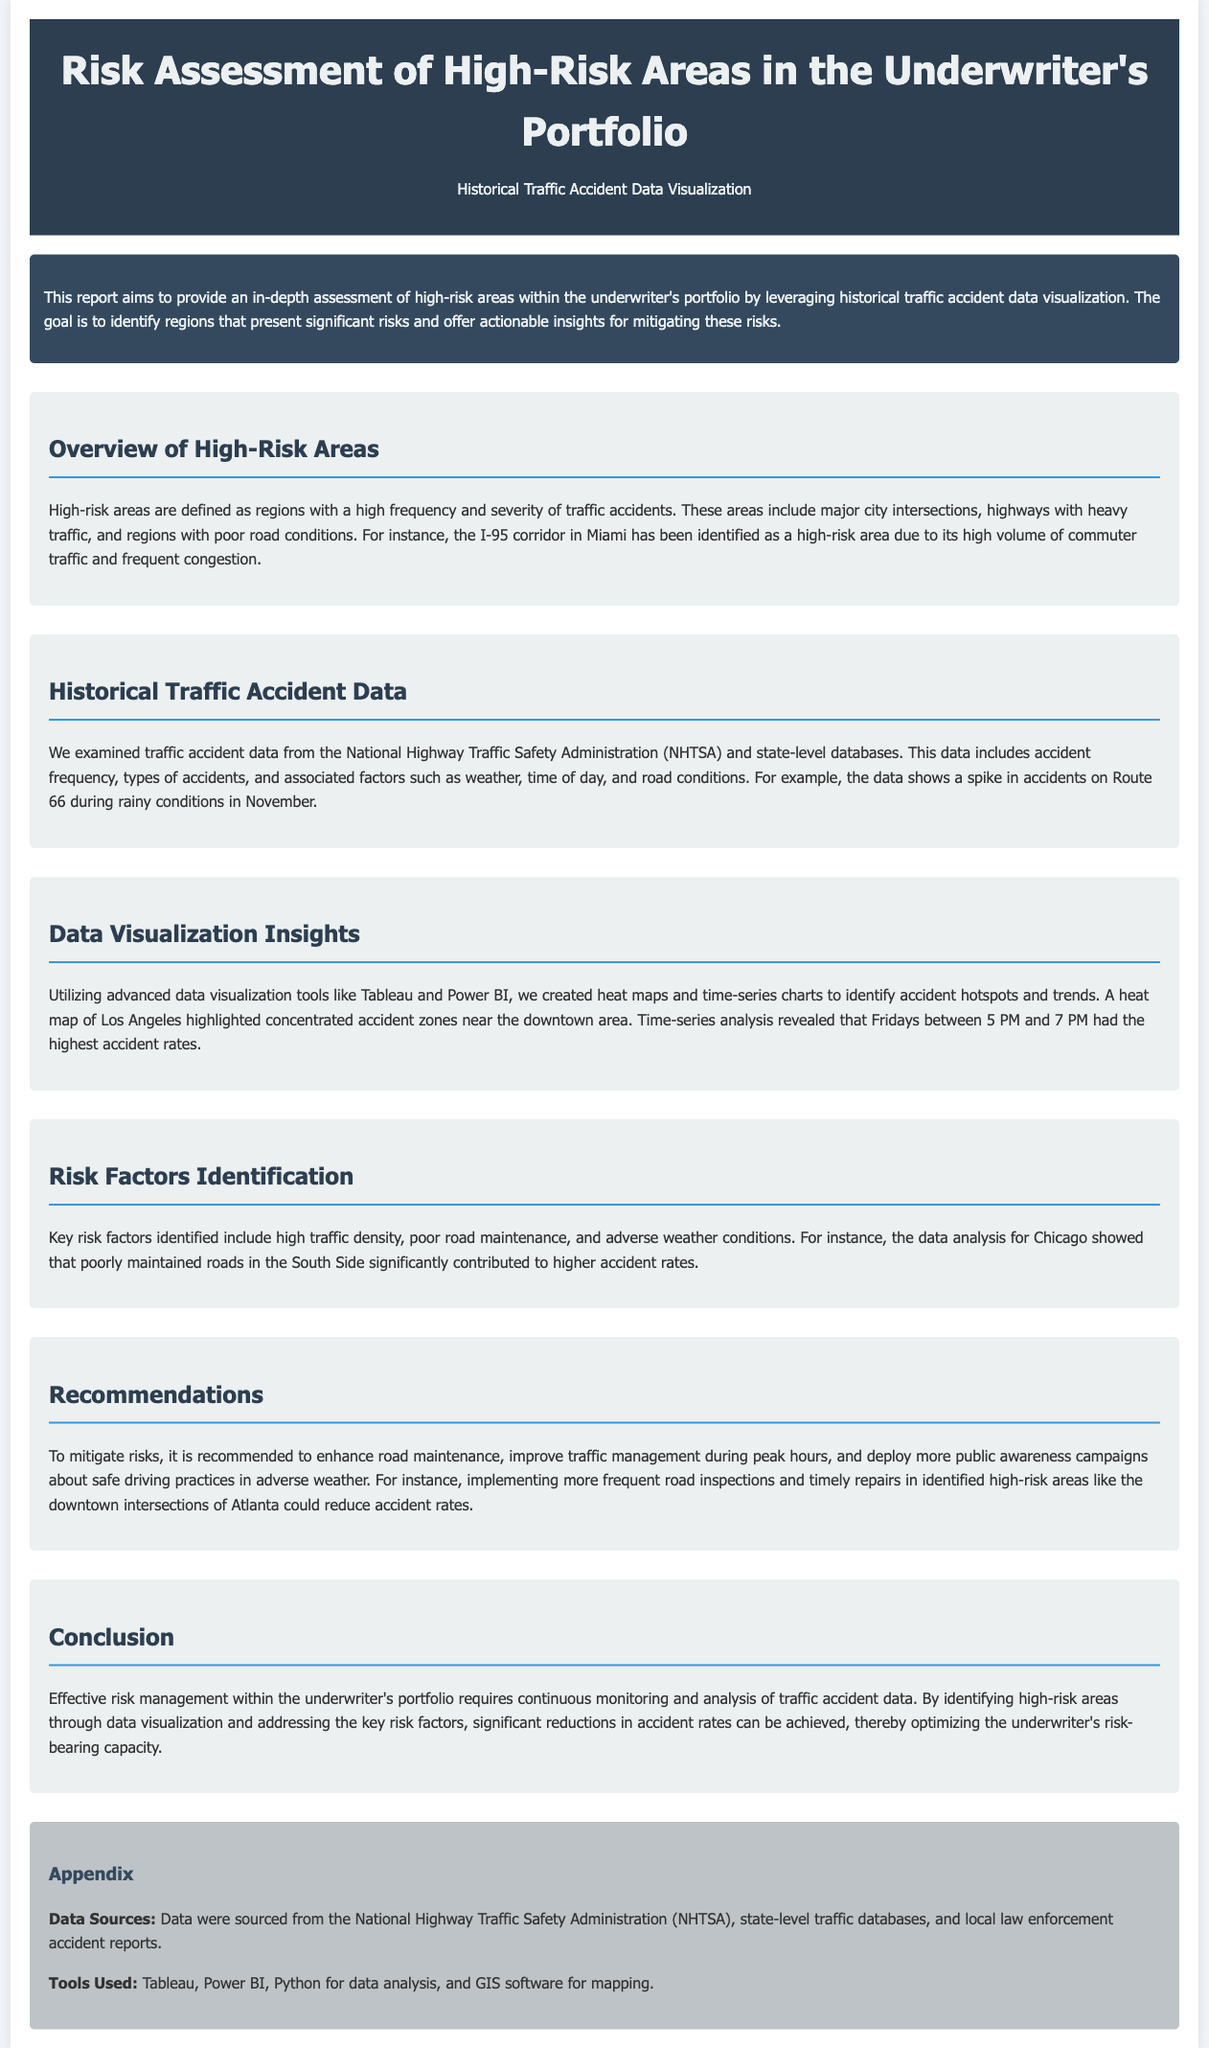what is the title of the report? The title of the report is presented clearly in the header section of the document.
Answer: Risk Assessment of High-Risk Areas in the Underwriter's Portfolio which tool was used for data visualization? The document mentions specific tools used for data visualization in the appendix section.
Answer: Tableau what is highlighted as a high-risk area in Miami? The document identifies a specific area in Miami that is considered high-risk due to traffic issues.
Answer: I-95 corridor when do accident rates peak according to the time-series analysis? The document states specific days and times when accident rates are highest based on analysis.
Answer: Fridays between 5 PM and 7 PM which risk factor is associated with higher accident rates in Chicago? The document specifies a key risk factor impacting accident rates on Chicago’s South Side.
Answer: Poor road maintenance what is recommended to address risks during peak hours? The document recommends a specific action to improve traffic management in busy times.
Answer: Improve traffic management what data source was used for the accident data? The document names a primary source for traffic accident data in the appendix section.
Answer: National Highway Traffic Safety Administration (NHTSA) which city is mentioned for having concentrated accident zones? The document points out a particular city known for its concentrated accident zones in the visualization insights section.
Answer: Los Angeles 